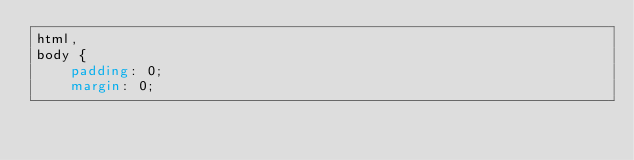<code> <loc_0><loc_0><loc_500><loc_500><_CSS_>html,
body {
    padding: 0;
    margin: 0;</code> 